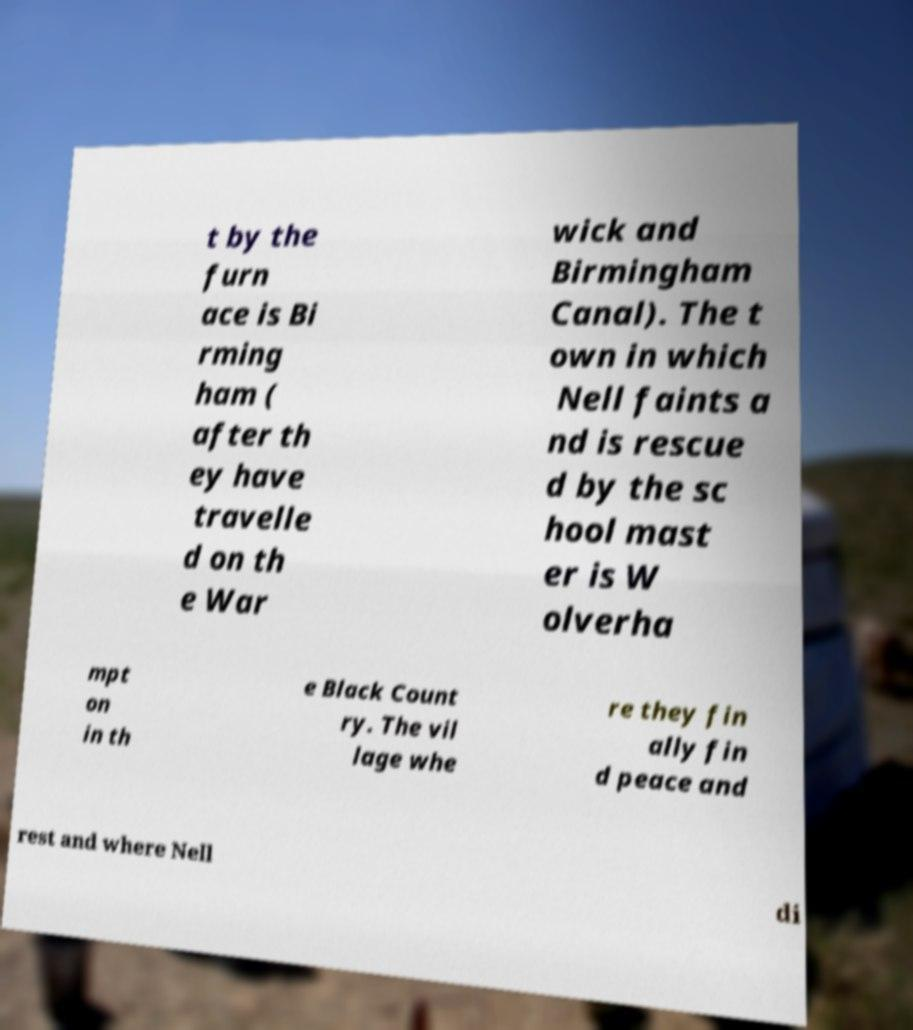Can you read and provide the text displayed in the image?This photo seems to have some interesting text. Can you extract and type it out for me? t by the furn ace is Bi rming ham ( after th ey have travelle d on th e War wick and Birmingham Canal). The t own in which Nell faints a nd is rescue d by the sc hool mast er is W olverha mpt on in th e Black Count ry. The vil lage whe re they fin ally fin d peace and rest and where Nell di 